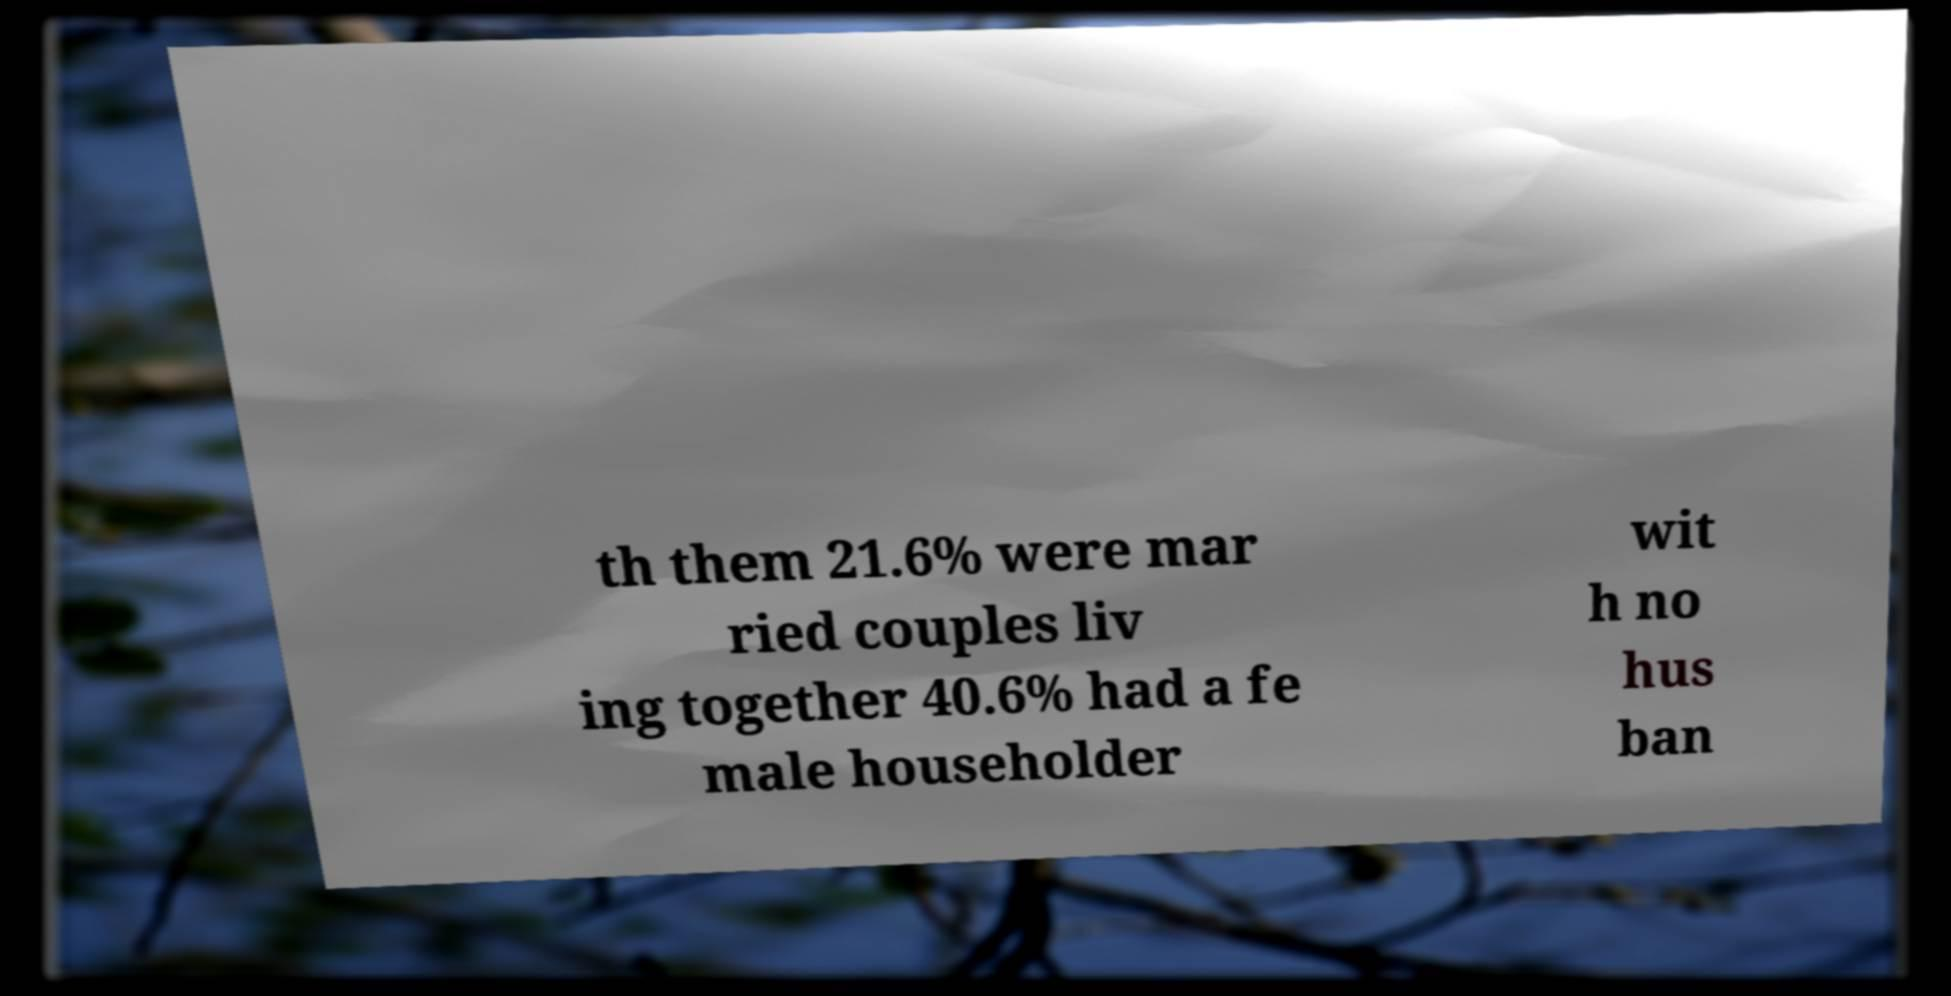Can you read and provide the text displayed in the image?This photo seems to have some interesting text. Can you extract and type it out for me? th them 21.6% were mar ried couples liv ing together 40.6% had a fe male householder wit h no hus ban 